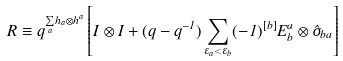Convert formula to latex. <formula><loc_0><loc_0><loc_500><loc_500>R \equiv q ^ { \underset { a } { \sum } h _ { a } \otimes h ^ { a } } \left [ I \otimes I + ( q - q ^ { - 1 } ) \sum _ { \varepsilon _ { a } < \varepsilon _ { b } } ( - 1 ) ^ { [ b ] } E ^ { a } _ { b } \otimes \hat { \sigma } _ { b a } \right ]</formula> 